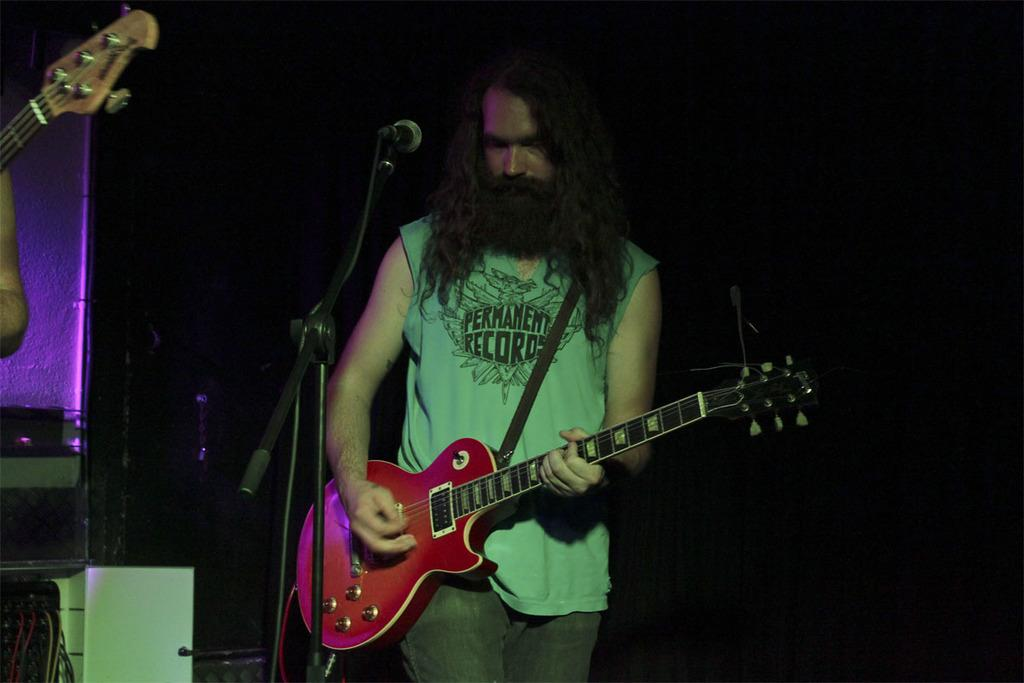What is the man in the image holding? The man is holding a guitar. What is the man standing in front of? The man is standing in front of a mic. Can you describe any other objects in the image? There is another guitar visible in the image. Whose hand can be seen in the image? There is a person's hand visible in the image. How many sisters are visible in the image? There are no sisters present in the image. What type of needle is being used by the man in the image? There is no needle visible in the image; the man is holding a guitar. 